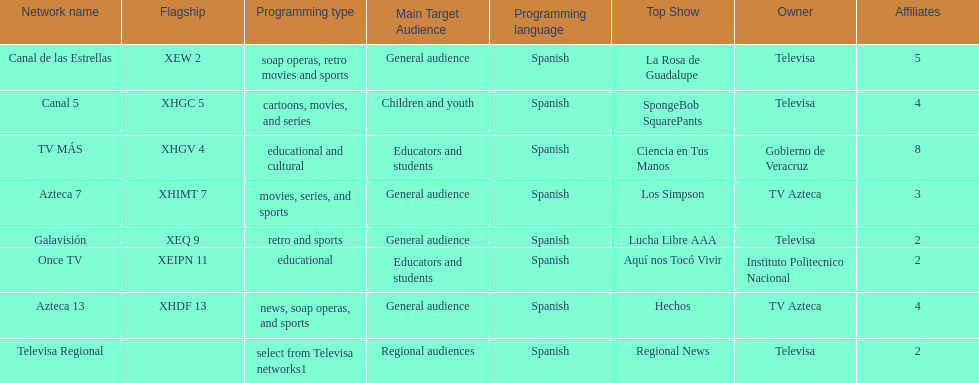Which owner has the most networks? Televisa. 